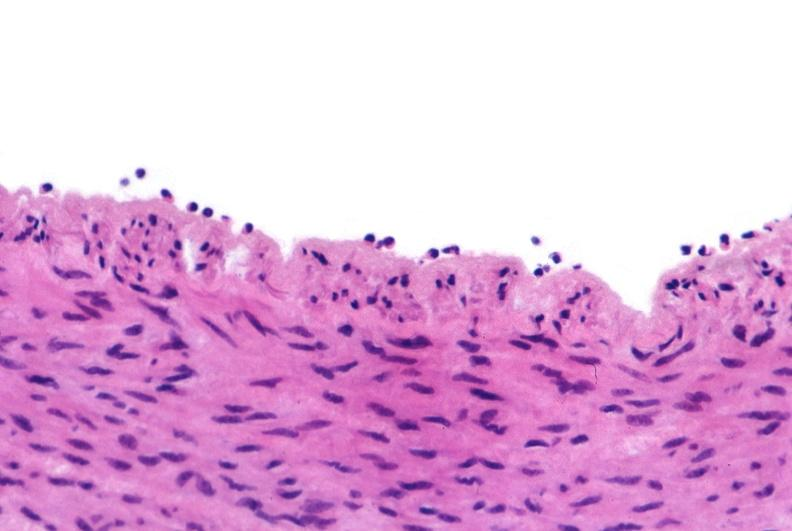s cardiovascular present?
Answer the question using a single word or phrase. Yes 